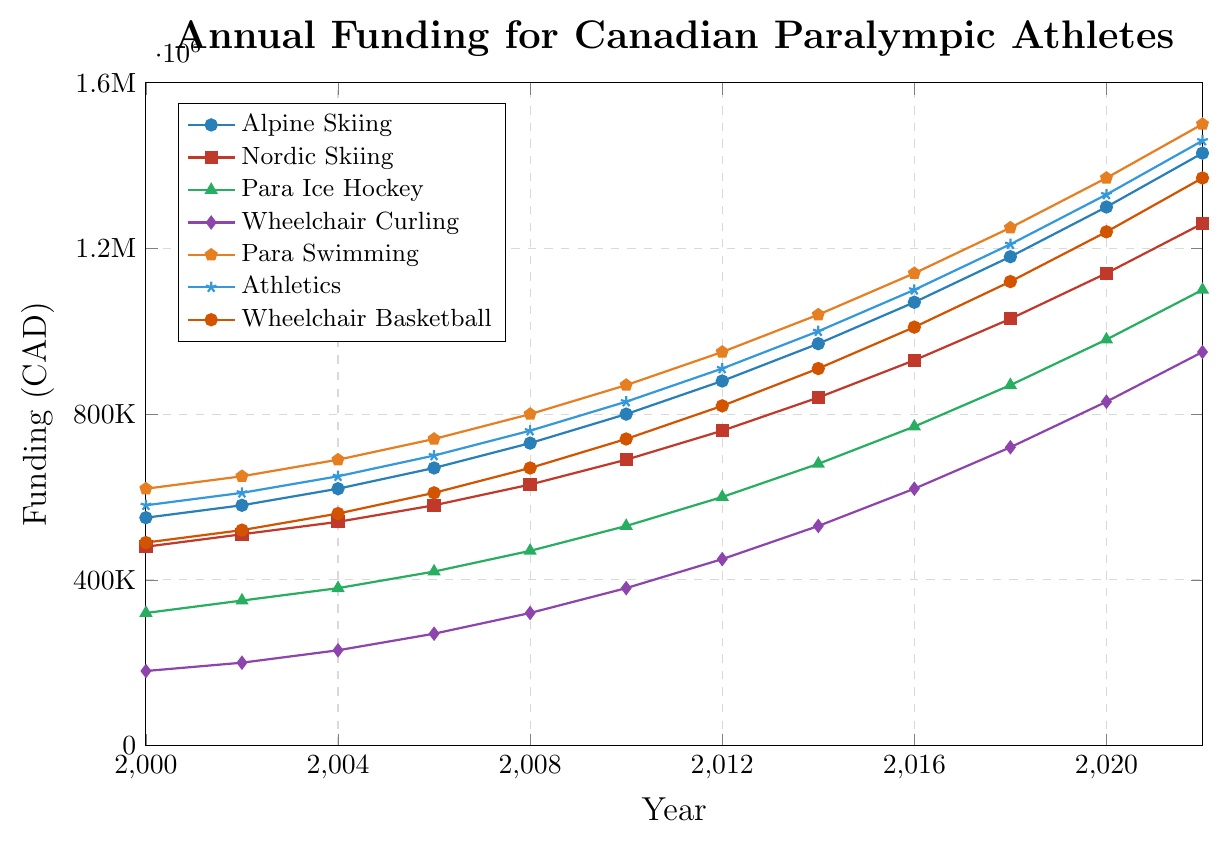What is the trend in funding for Para Ice Hockey from 2000 to 2022? The funding for Para Ice Hockey shows a consistent increasing trend from 320,000 CAD in 2000 to 1,100,000 CAD in 2022.
Answer: Increasing trend Which sport received the highest funding in 2022? By observing the endpoint in 2022, the sport with the highest funding is Para Swimming at 1,500,000 CAD.
Answer: Para Swimming How much more funding did Athletics receive in 2020 compared to 2008? In 2020, Athletics received 1,330,000 CAD, and in 2008, it received 760,000 CAD. The difference in funding is 1,330,000 - 760,000 = 570,000 CAD.
Answer: 570,000 CAD Compare the funding growth between Wheelchair Curling and Wheelchair Basketball from 2000 to 2022. Which one grew more? The funding for Wheelchair Curling grew from 180,000 CAD in 2000 to 950,000 CAD in 2022, an increase of 770,000 CAD. The funding for Wheelchair Basketball grew from 490,000 CAD in 2000 to 1,370,000 CAD in 2022, an increase of 880,000 CAD. Therefore, Wheelchair Basketball grew more.
Answer: Wheelchair Basketball What is the average funding for Nordic Skiing from 2000 to 2022? The funding values for Nordic Skiing from 2000 to 2022 are: 480,000, 510,000, 540,000, 580,000, 630,000, 690,000, 760,000, 840,000, 930,000, 1,030,000, 1,140,000, 1,260,000 CAD. The average funding is the sum of these values divided by 12, which is (480,000 + 510,000 + 540,000 + 580,000 + 630,000 + 690,000 + 760,000 + 840,000 + 930,000 + 1,030,000 + 1,140,000 + 1,260,000) / 12 = 760,000 CAD.
Answer: 760,000 CAD In which year did Alpine Skiing surpass 1 million CAD in funding? By observing the line for Alpine Skiing, we see that its funding surpasses 1 million CAD in 2016.
Answer: 2016 Which sport had the smallest funding increase from 2000 to 2022? Comparing the start and end values, Wheelchair Curling had the smallest increase from 180,000 CAD in 2000 to 950,000 CAD in 2022, an increase of 770,000 CAD.
Answer: Wheelchair Curling What is the combined total funding for all sports in 2010? The funding for each sport in 2010: Alpine Skiing (800,000), Nordic Skiing (690,000), Para Ice Hockey (530,000), Wheelchair Curling (380,000), Para Swimming (870,000), Athletics (830,000), Wheelchair Basketball (740,000). Combined total is 800,000 + 690,000 + 530,000 + 380,000 + 870,000 + 830,000 + 740,000 = 4,840,000 CAD.
Answer: 4,840,000 CAD Between which consecutive years did Para Swimming experience the highest increase in funding? By analyzing the increments, from 2014 to 2016 Para Swimming's funding increased from 1,040,000 CAD to 1,140,000 CAD, an increase of 100,000 CAD, which is the highest consecutive increase.
Answer: 2014 to 2016 